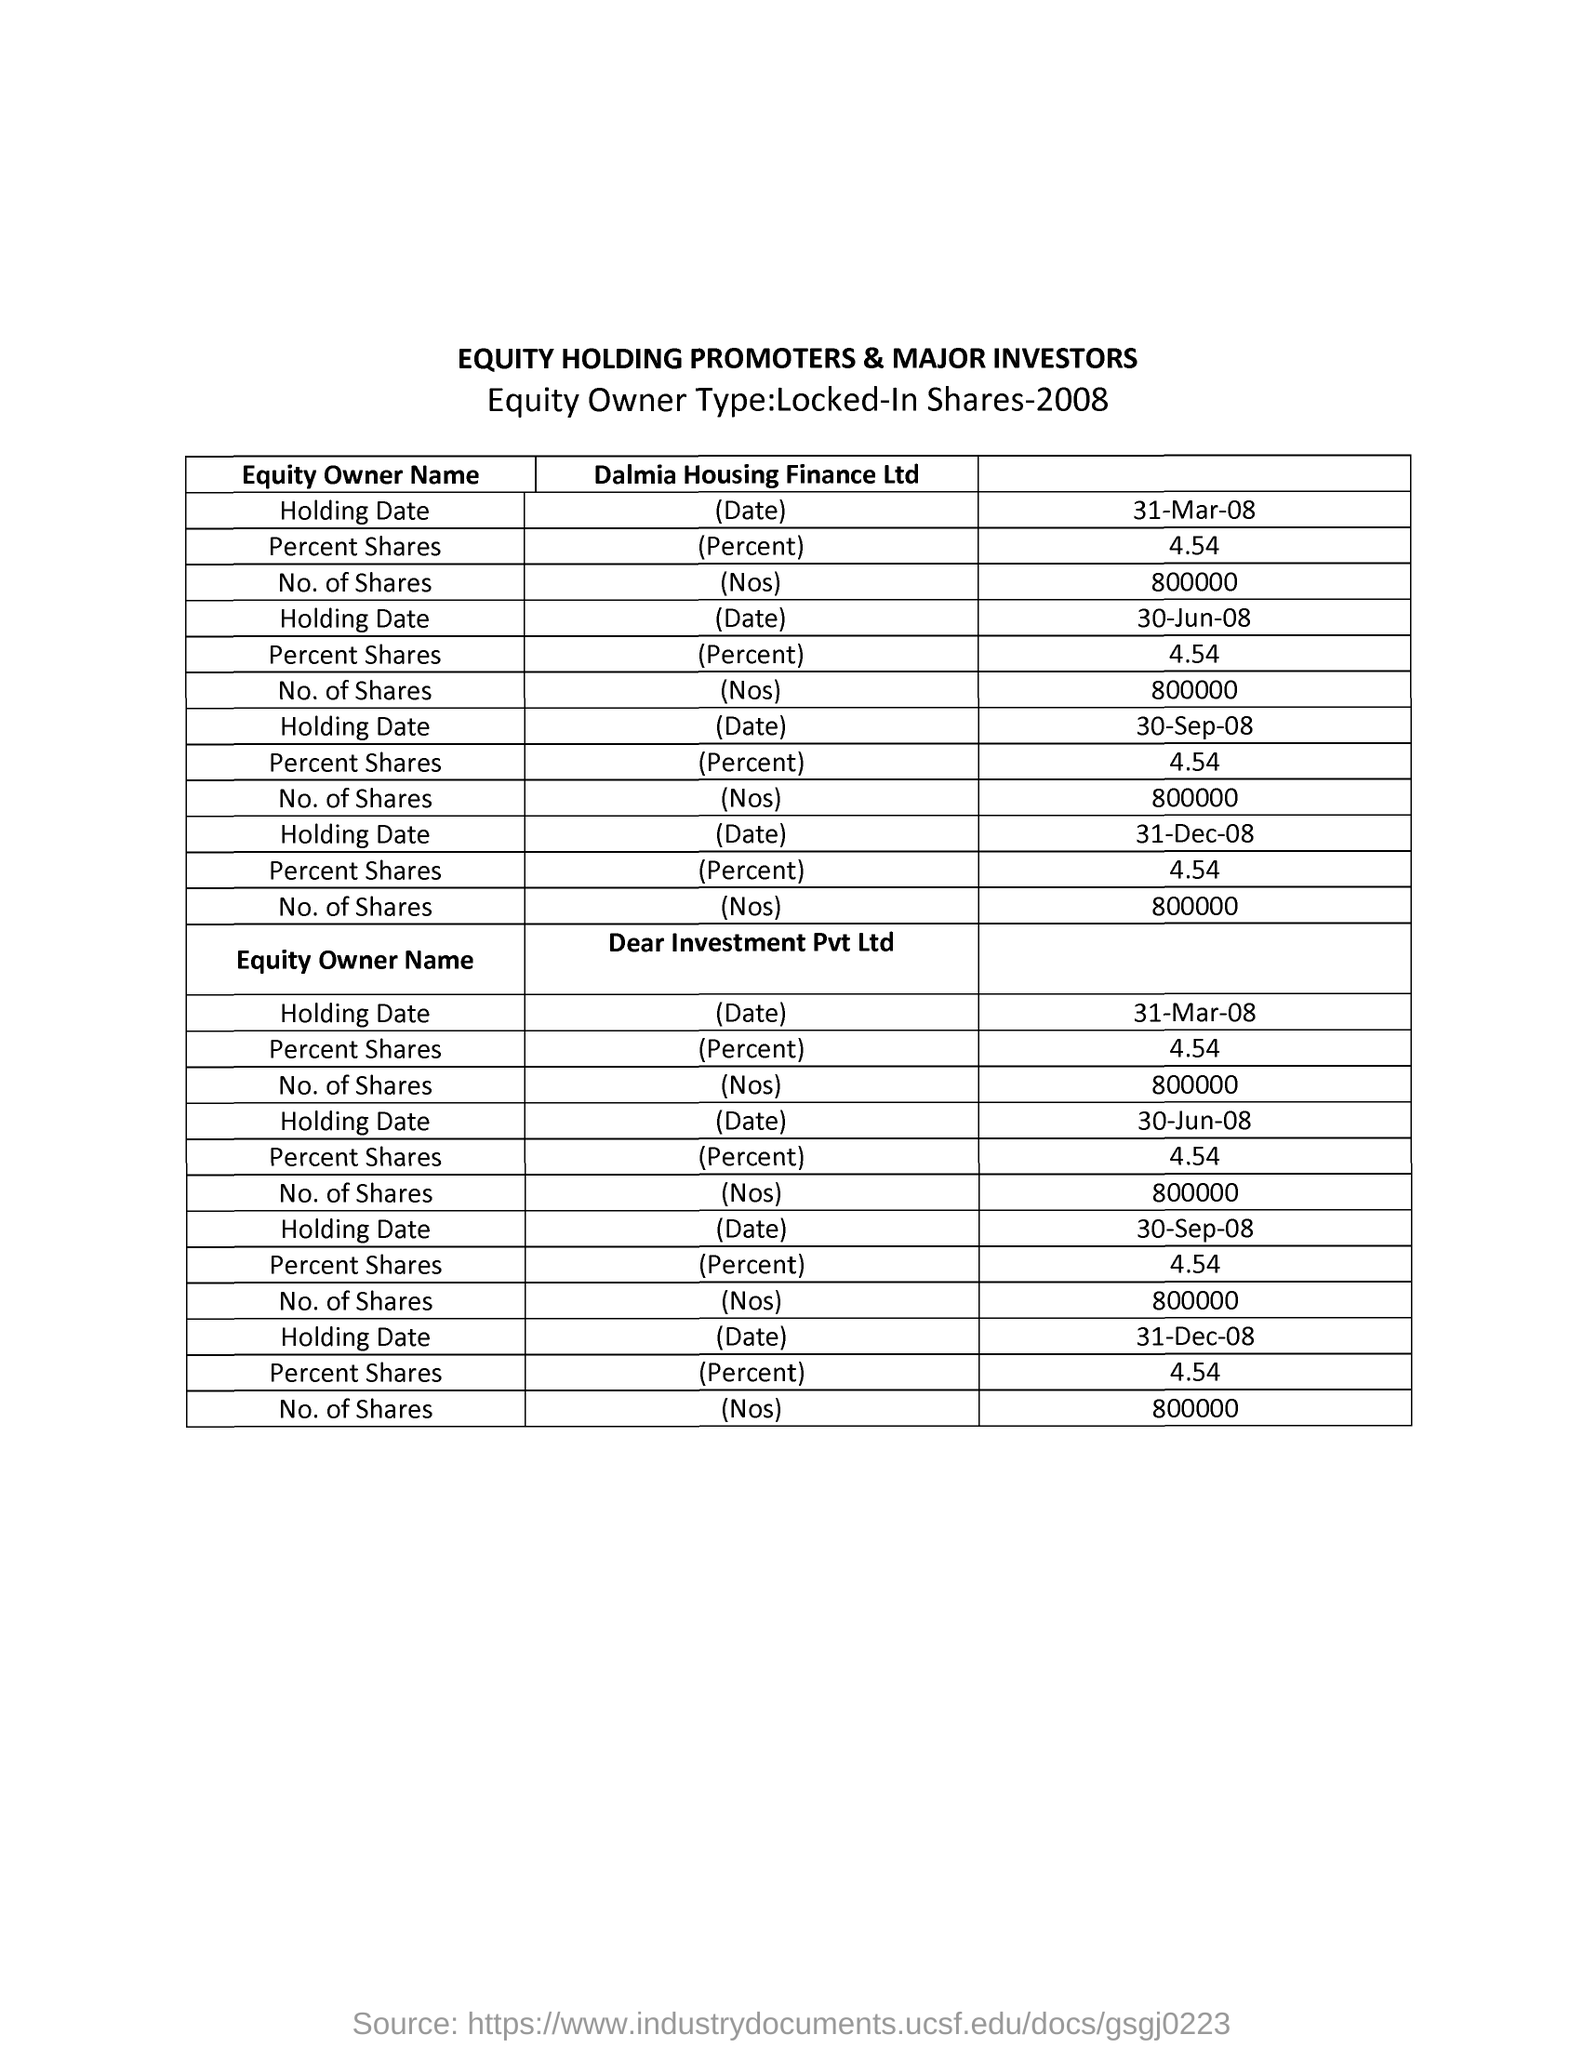Point out several critical features in this image. The first holding date of equity for Dear Investment Pvt Ltd was March 31, 2008. The second column heading of the second table is 'Dear Investment Pvt Ltd..' The last holding date of equity ownership for Dalmia Housing Finance Ltd mentioned is December 31, 2008. The information provided refers to "Locked-in Shares" details for a specific year, which is 2008. The first column heading of the table is 'Equity Owner Name.' 